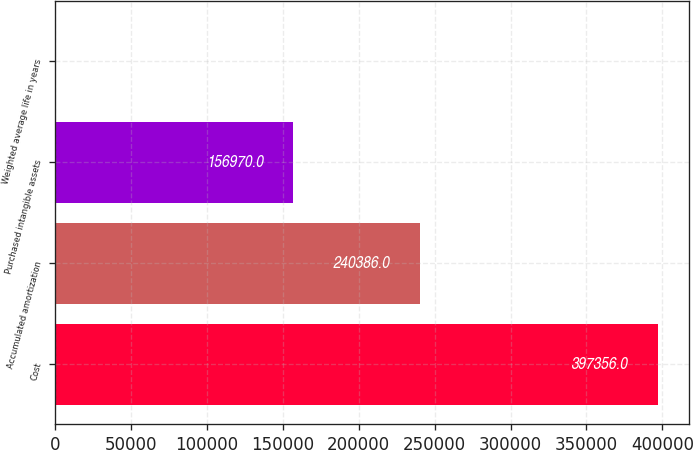<chart> <loc_0><loc_0><loc_500><loc_500><bar_chart><fcel>Cost<fcel>Accumulated amortization<fcel>Purchased intangible assets<fcel>Weighted average life in years<nl><fcel>397356<fcel>240386<fcel>156970<fcel>5<nl></chart> 